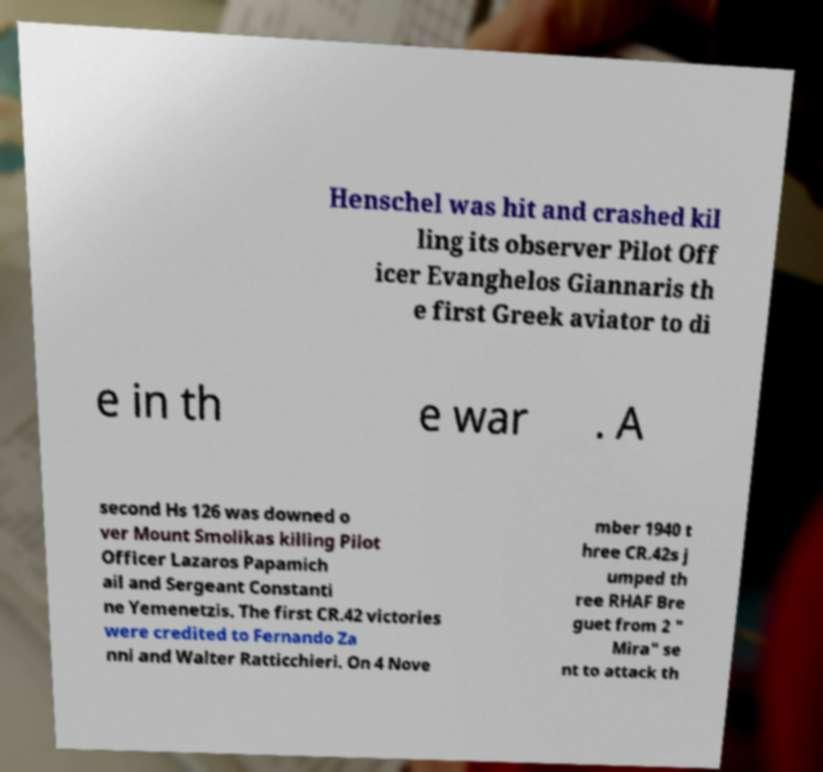I need the written content from this picture converted into text. Can you do that? Henschel was hit and crashed kil ling its observer Pilot Off icer Evanghelos Giannaris th e first Greek aviator to di e in th e war . A second Hs 126 was downed o ver Mount Smolikas killing Pilot Officer Lazaros Papamich ail and Sergeant Constanti ne Yemenetzis. The first CR.42 victories were credited to Fernando Za nni and Walter Ratticchieri. On 4 Nove mber 1940 t hree CR.42s j umped th ree RHAF Bre guet from 2 " Mira" se nt to attack th 